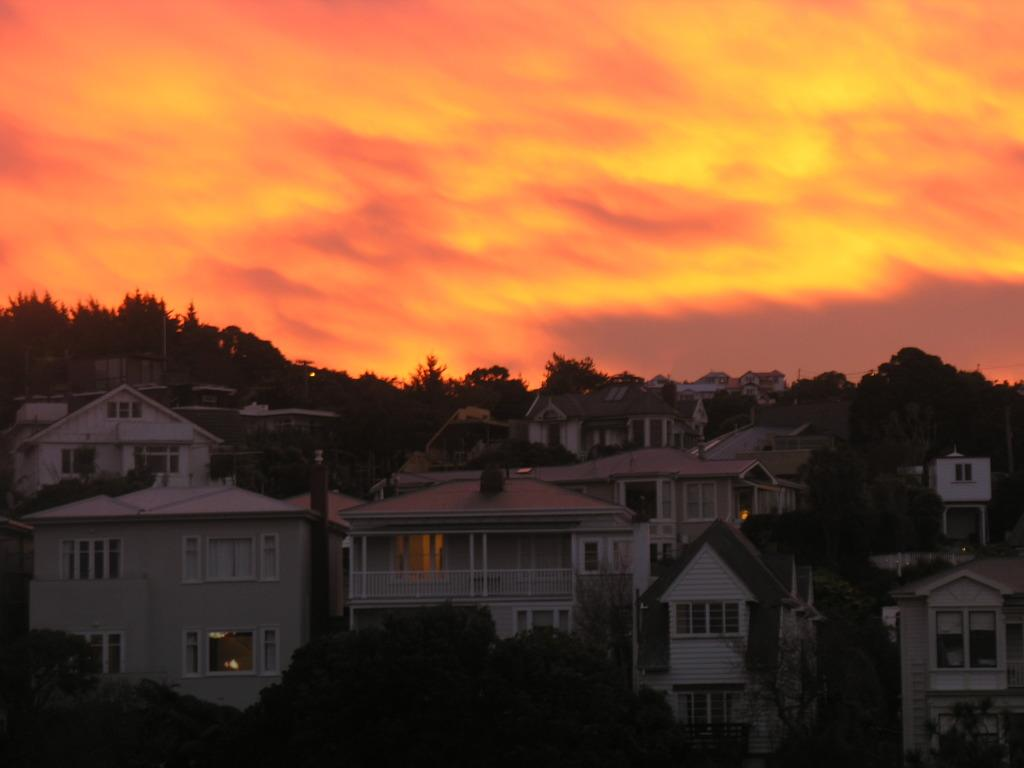What type of structures can be seen in the image? There are many houses in the image. What features do the houses have? The houses have roofs, windows, pillars, and balconies. What else can be seen in the image besides the houses? There are many trees and poles in the image. What is visible at the top of the image? The sky is visible at the top of the image, and there are clouds in the sky. Where is the kettle located in the image? There is no kettle present in the image. What type of glue is being used to hold the ocean in the image? There is no ocean or glue present in the image. 